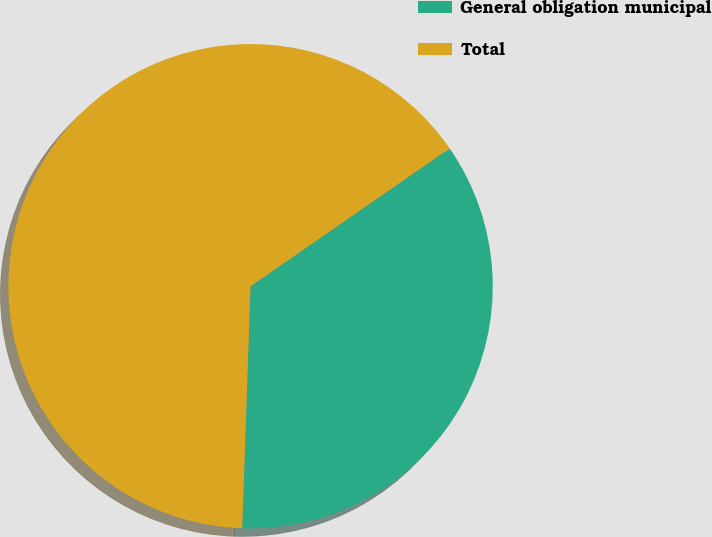<chart> <loc_0><loc_0><loc_500><loc_500><pie_chart><fcel>General obligation municipal<fcel>Total<nl><fcel>35.19%<fcel>64.81%<nl></chart> 